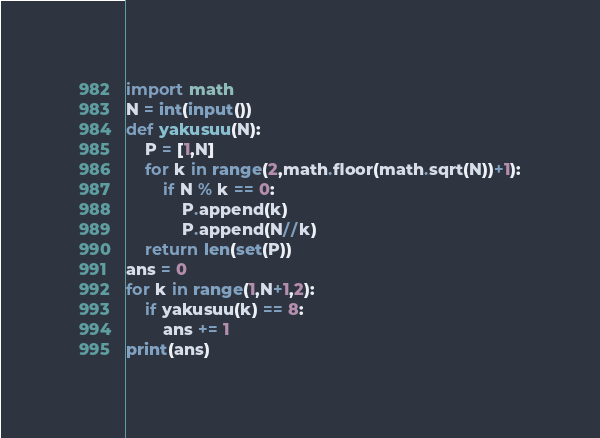<code> <loc_0><loc_0><loc_500><loc_500><_Python_>import math
N = int(input())
def yakusuu(N):
    P = [1,N]
    for k in range(2,math.floor(math.sqrt(N))+1):
        if N % k == 0:
            P.append(k)
            P.append(N//k)
    return len(set(P))
ans = 0
for k in range(1,N+1,2):
    if yakusuu(k) == 8:
        ans += 1
print(ans)
</code> 